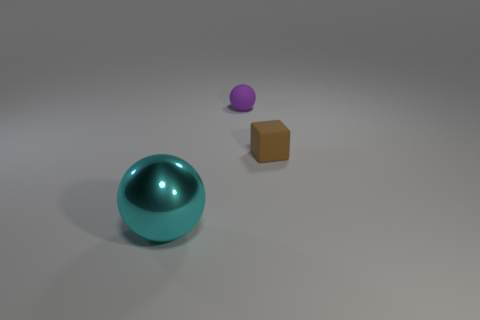Are there any other things that are the same shape as the small brown matte thing?
Your answer should be very brief. No. There is a matte cube that is the same size as the purple ball; what is its color?
Your response must be concise. Brown. Do the shiny ball and the purple matte sphere have the same size?
Offer a very short reply. No. How big is the thing that is both on the left side of the small brown matte object and in front of the tiny purple sphere?
Your answer should be very brief. Large. What number of matte things are either tiny balls or tiny blue balls?
Your answer should be compact. 1. Are there more rubber things that are behind the brown rubber thing than tiny blue rubber balls?
Give a very brief answer. Yes. What is the ball on the left side of the purple object made of?
Your answer should be very brief. Metal. What number of small things have the same material as the small cube?
Ensure brevity in your answer.  1. What shape is the object that is left of the brown matte block and in front of the tiny purple matte thing?
Keep it short and to the point. Sphere. What number of things are balls on the right side of the big cyan object or balls behind the brown object?
Make the answer very short. 1. 